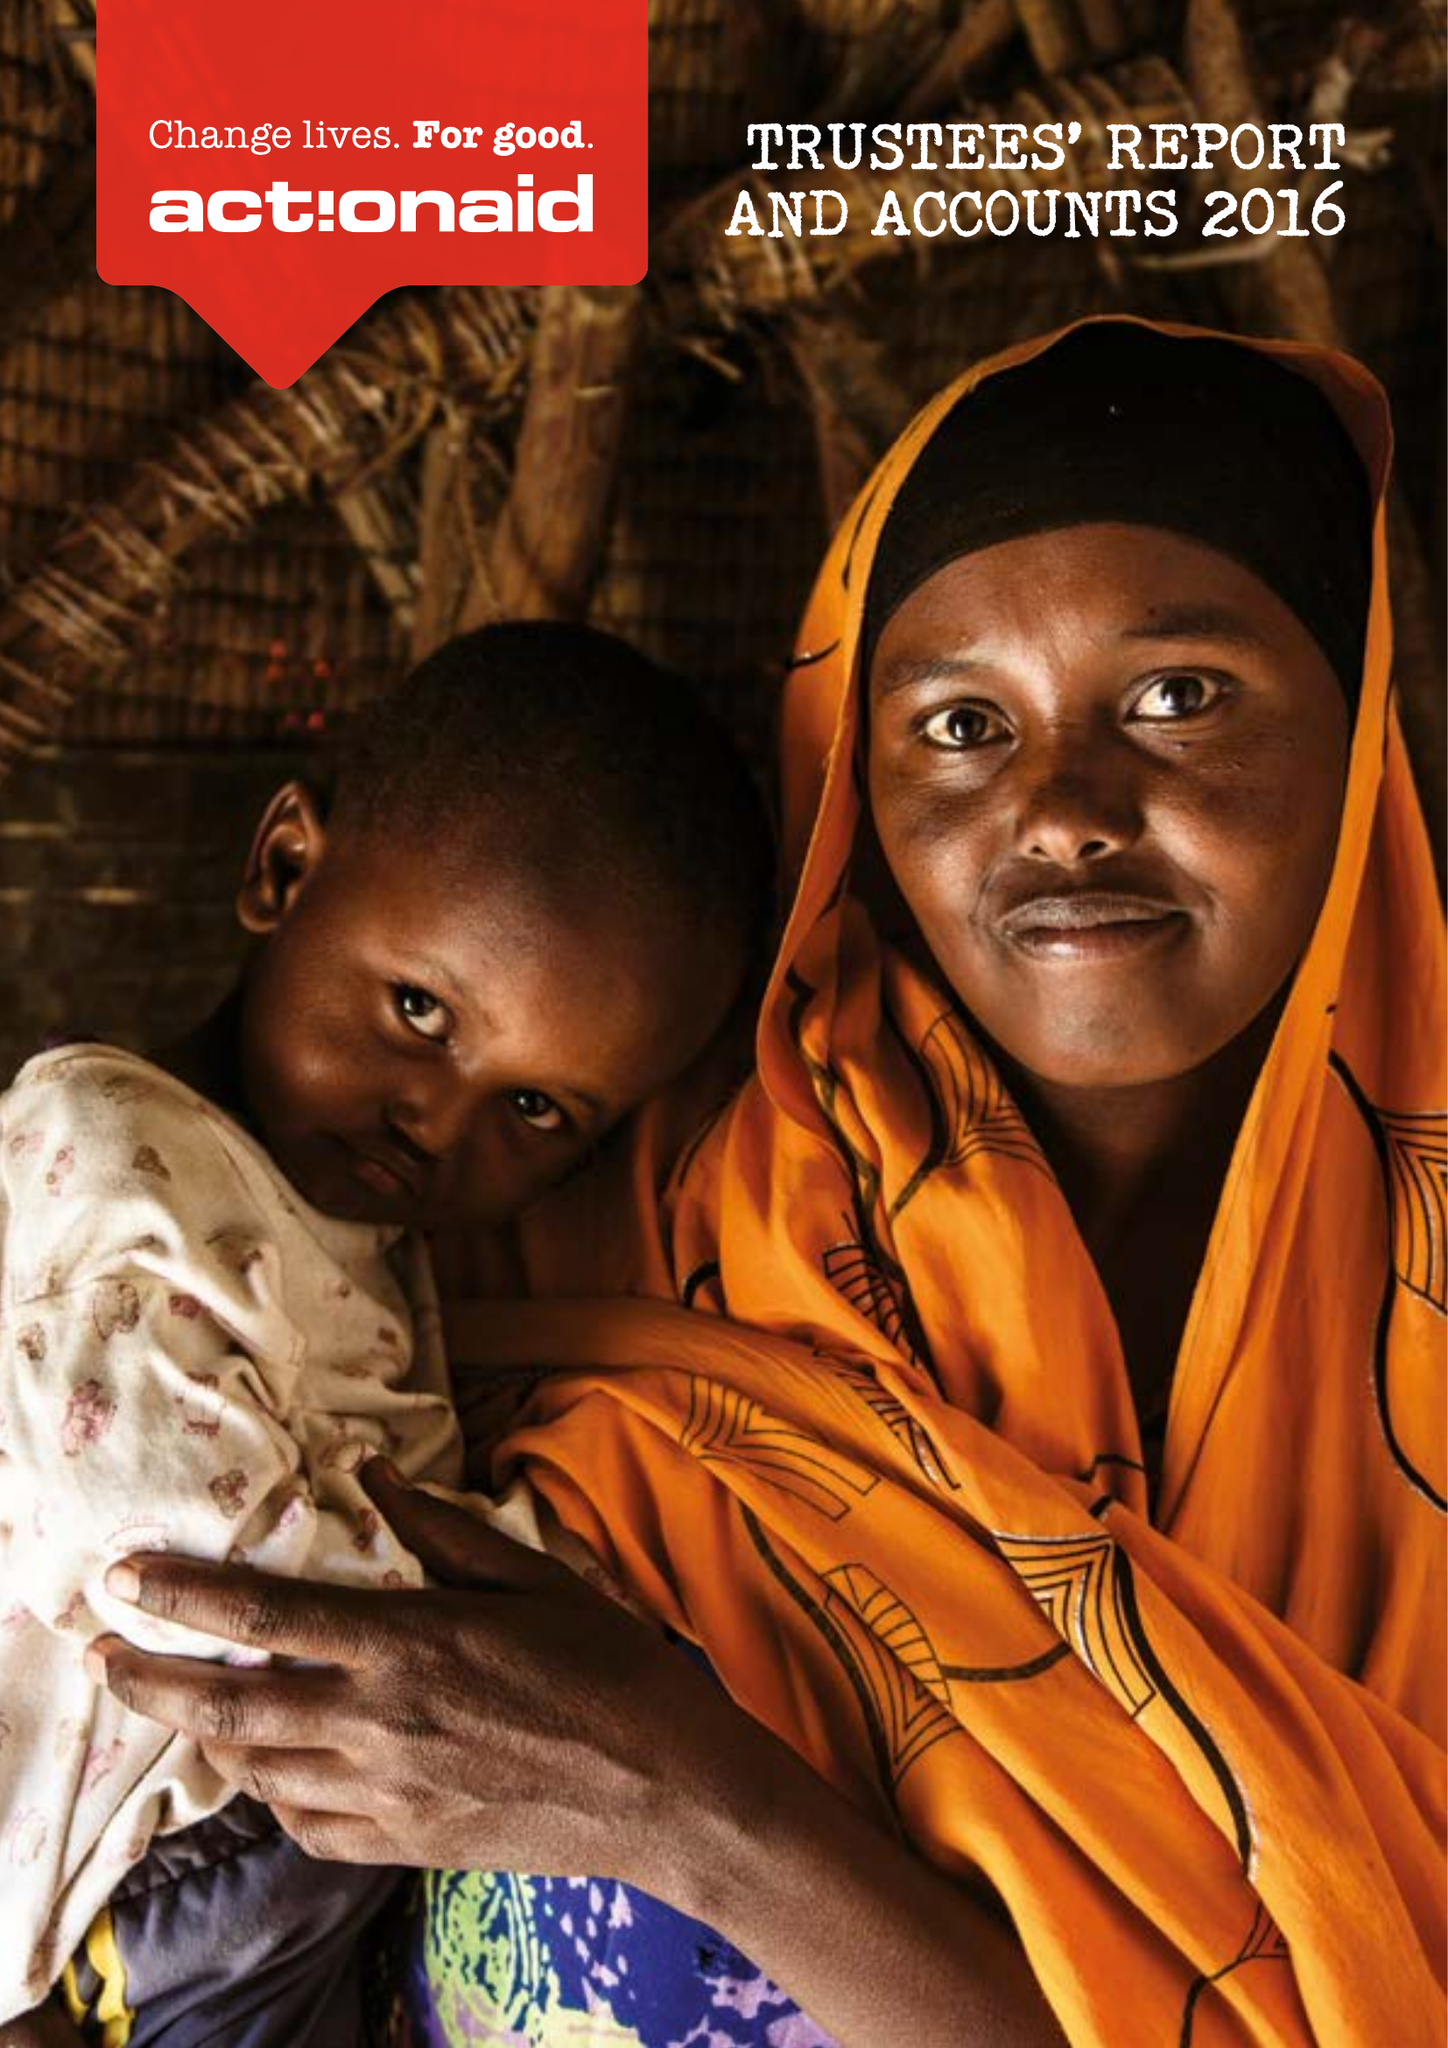What is the value for the report_date?
Answer the question using a single word or phrase. 2016-12-31 